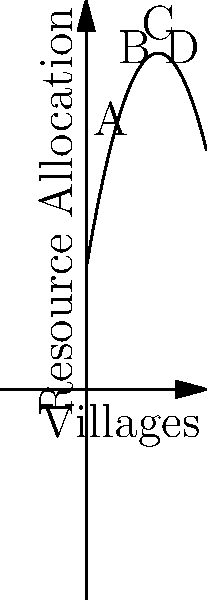As the overseer of rural development projects, you're tasked with optimizing resource allocation across four villages (A, B, C, and D) represented by the polynomial function $f(x) = -0.5x^2 + 6x + 10$, where $x$ represents the village's position (2, 4, 6, and 8 respectively) and $f(x)$ represents the optimal resource allocation. Which village should receive the most resources, and what is the maximum resource allocation value? To solve this problem, we need to follow these steps:

1) The polynomial function given is $f(x) = -0.5x^2 + 6x + 10$.

2) We need to calculate the resource allocation for each village:

   Village A (x = 2): $f(2) = -0.5(2)^2 + 6(2) + 10 = -2 + 12 + 10 = 20$
   Village B (x = 4): $f(4) = -0.5(4)^2 + 6(4) + 10 = -8 + 24 + 10 = 26$
   Village C (x = 6): $f(6) = -0.5(6)^2 + 6(6) + 10 = -18 + 36 + 10 = 28$
   Village D (x = 8): $f(8) = -0.5(8)^2 + 6(8) + 10 = -32 + 48 + 10 = 26$

3) From these calculations, we can see that Village C should receive the most resources.

4) To find the maximum resource allocation, we need to find the vertex of the parabola. For a quadratic function $f(x) = ax^2 + bx + c$, the x-coordinate of the vertex is given by $x = -b/(2a)$.

5) In this case, $a = -0.5$, $b = 6$, so:
   $x = -6 / (2(-0.5)) = 6$

6) This confirms that the maximum occurs at x = 6, which corresponds to Village C.

7) The maximum resource allocation is therefore $f(6) = 28$.
Answer: Village C; 28 units 